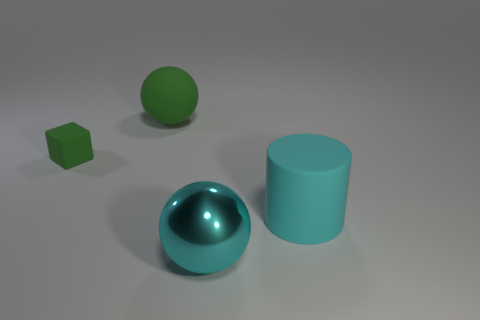Add 2 big purple matte cylinders. How many objects exist? 6 Subtract all blocks. How many objects are left? 3 Subtract all large green metal objects. Subtract all big cyan spheres. How many objects are left? 3 Add 2 metal things. How many metal things are left? 3 Add 2 small green matte cubes. How many small green matte cubes exist? 3 Subtract 0 brown cubes. How many objects are left? 4 